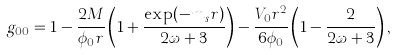Convert formula to latex. <formula><loc_0><loc_0><loc_500><loc_500>g _ { 0 0 } = 1 - \frac { 2 M } { \phi _ { 0 } r } \left ( 1 + \frac { \exp ( - m _ { s } r ) } { 2 \omega + 3 } \right ) - \frac { V _ { 0 } r ^ { 2 } } { 6 \phi _ { 0 } } \left ( 1 - \frac { 2 } { 2 \omega + 3 } \right ) ,</formula> 